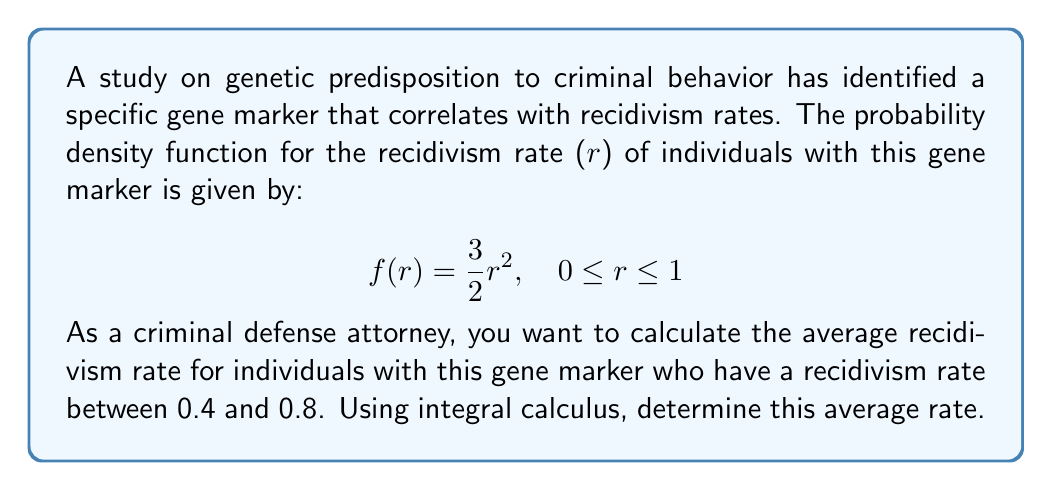Teach me how to tackle this problem. To solve this problem, we'll use the concept of expected value from probability theory, which can be calculated using integral calculus.

Step 1: The average (expected value) of a continuous random variable over an interval [a,b] is given by:

$$E[X] = \frac{\int_a^b x f(x) dx}{\int_a^b f(x) dx}$$

Step 2: In our case, a = 0.4, b = 0.8, and f(r) = 3/2 * r^2. Let's calculate the numerator and denominator separately.

Step 3: Numerator calculation:
$$\int_{0.4}^{0.8} r \cdot \frac{3}{2}r^2 dr = \frac{3}{2}\int_{0.4}^{0.8} r^3 dr = \frac{3}{2} \cdot \frac{r^4}{4}\bigg|_{0.4}^{0.8}$$
$$= \frac{3}{8}(0.8^4 - 0.4^4) = \frac{3}{8}(0.4096 - 0.0256) = 0.144$$

Step 4: Denominator calculation:
$$\int_{0.4}^{0.8} \frac{3}{2}r^2 dr = \frac{3}{2} \cdot \frac{r^3}{3}\bigg|_{0.4}^{0.8}$$
$$= \frac{1}{2}(0.8^3 - 0.4^3) = \frac{1}{2}(0.512 - 0.064) = 0.224$$

Step 5: Calculate the average recidivism rate:
$$E[R] = \frac{0.144}{0.224} = \frac{9}{14} \approx 0.6429$$

Therefore, the average recidivism rate for individuals with this gene marker who have a recidivism rate between 0.4 and 0.8 is approximately 0.6429 or 64.29%.
Answer: $\frac{9}{14}$ or approximately 0.6429 